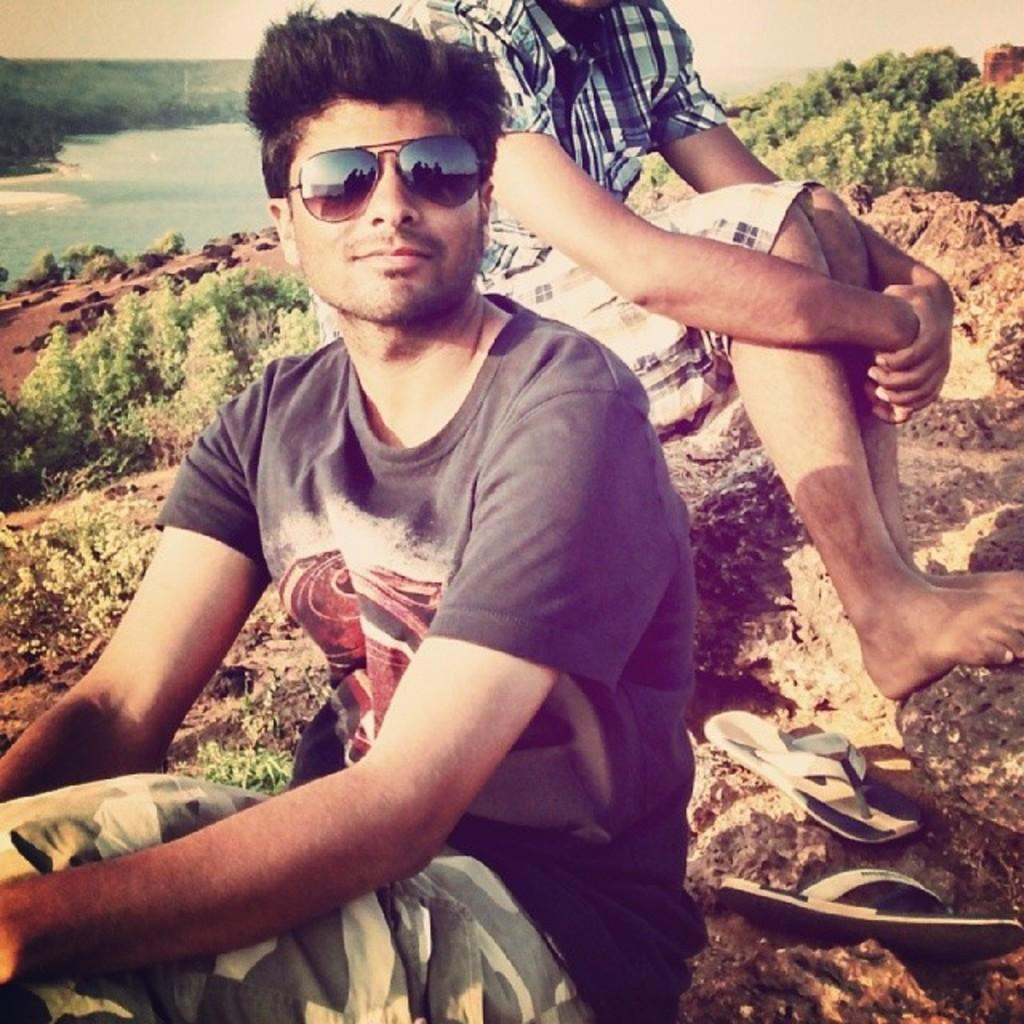How many men are sitting on the rock in the image? There are two men sitting on the rock in the image. What is on the rock besides the men? There is footwear on the rock. What can be seen in the background of the image? In the background, there are plants, stones, water, trees, and the sky. What type of credit card is visible in the image? There is no credit card present in the image. What is the men using to hammer the stones in the image? There is no hammer or hammering activity depicted in the image. 